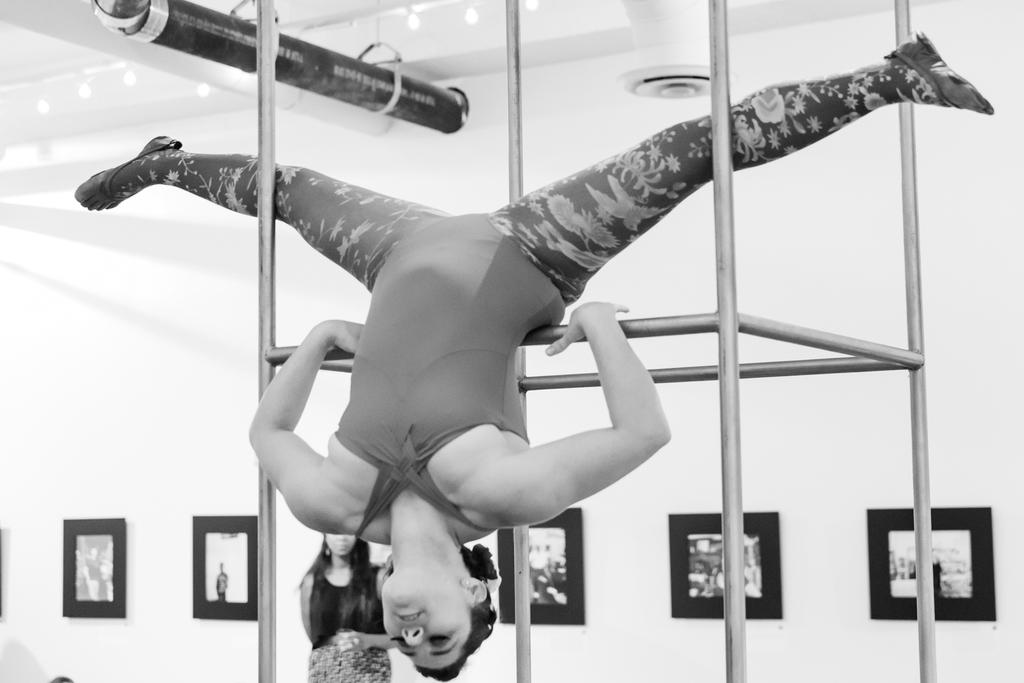What is the color of the wall in the image? There is a white color wall in the image. What objects are present on the wall in the image? There are photo frames in the image. How many women are in the image? There are two women in the image. What type of spy equipment can be seen in the image? There is no spy equipment present in the image. What type of clothing are the women wearing in the image? The provided facts do not mention the type of clothing the women are wearing. 